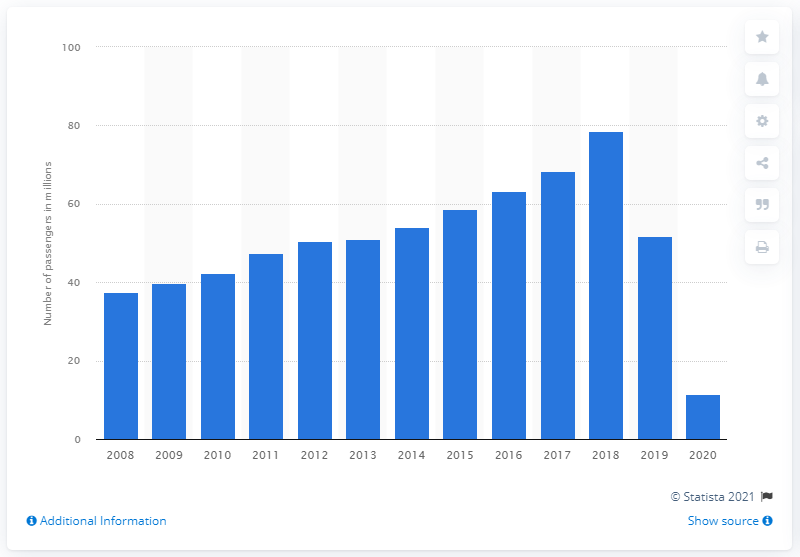Give some essential details in this illustration. The COVID-19 pandemic began in December 2019 and reached a global pandemic level in January 2020. In 2020, easyJet lifted a total of 11,420 passengers in the United Kingdom. 